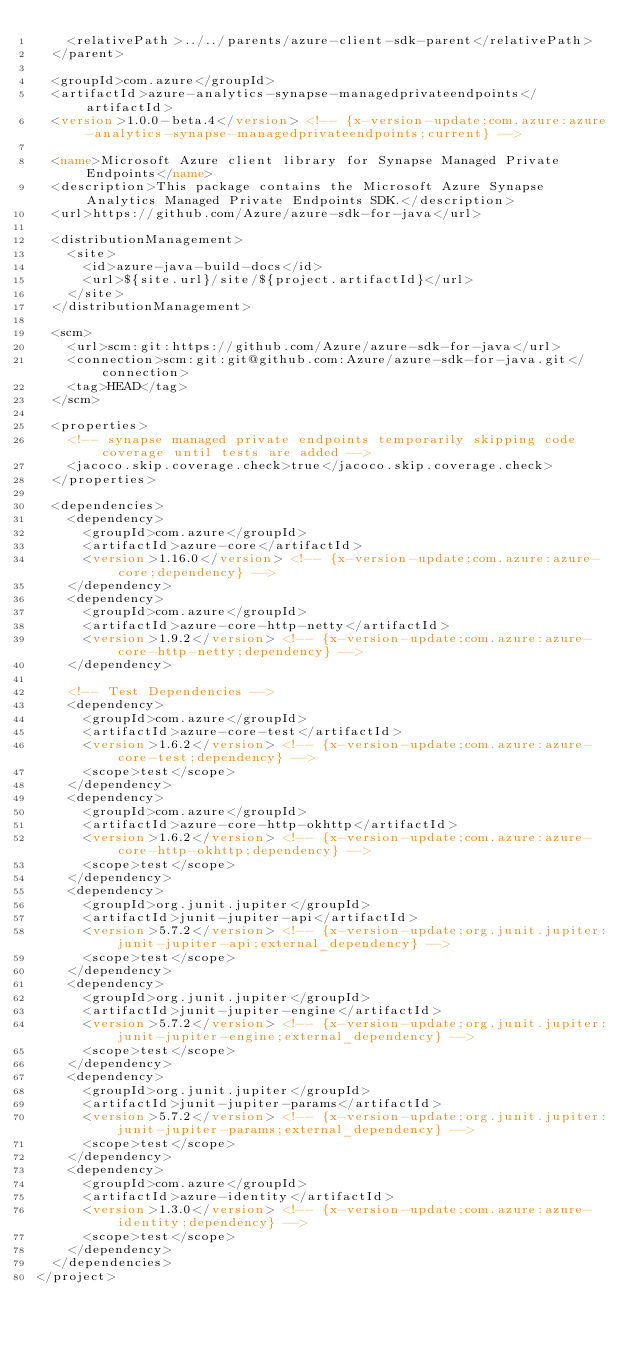Convert code to text. <code><loc_0><loc_0><loc_500><loc_500><_XML_>    <relativePath>../../parents/azure-client-sdk-parent</relativePath>
  </parent>

  <groupId>com.azure</groupId>
  <artifactId>azure-analytics-synapse-managedprivateendpoints</artifactId>
  <version>1.0.0-beta.4</version> <!-- {x-version-update;com.azure:azure-analytics-synapse-managedprivateendpoints;current} -->

  <name>Microsoft Azure client library for Synapse Managed Private Endpoints</name>
  <description>This package contains the Microsoft Azure Synapse Analytics Managed Private Endpoints SDK.</description>
  <url>https://github.com/Azure/azure-sdk-for-java</url>

  <distributionManagement>
    <site>
      <id>azure-java-build-docs</id>
      <url>${site.url}/site/${project.artifactId}</url>
    </site>
  </distributionManagement>

  <scm>
    <url>scm:git:https://github.com/Azure/azure-sdk-for-java</url>
    <connection>scm:git:git@github.com:Azure/azure-sdk-for-java.git</connection>
    <tag>HEAD</tag>
  </scm>

  <properties>
    <!-- synapse managed private endpoints temporarily skipping code coverage until tests are added -->
    <jacoco.skip.coverage.check>true</jacoco.skip.coverage.check>
  </properties>

  <dependencies>
    <dependency>
      <groupId>com.azure</groupId>
      <artifactId>azure-core</artifactId>
      <version>1.16.0</version> <!-- {x-version-update;com.azure:azure-core;dependency} -->
    </dependency>
    <dependency>
      <groupId>com.azure</groupId>
      <artifactId>azure-core-http-netty</artifactId>
      <version>1.9.2</version> <!-- {x-version-update;com.azure:azure-core-http-netty;dependency} -->
    </dependency>

    <!-- Test Dependencies -->
    <dependency>
      <groupId>com.azure</groupId>
      <artifactId>azure-core-test</artifactId>
      <version>1.6.2</version> <!-- {x-version-update;com.azure:azure-core-test;dependency} -->
      <scope>test</scope>
    </dependency>
    <dependency>
      <groupId>com.azure</groupId>
      <artifactId>azure-core-http-okhttp</artifactId>
      <version>1.6.2</version> <!-- {x-version-update;com.azure:azure-core-http-okhttp;dependency} -->
      <scope>test</scope>
    </dependency>
    <dependency>
      <groupId>org.junit.jupiter</groupId>
      <artifactId>junit-jupiter-api</artifactId>
      <version>5.7.2</version> <!-- {x-version-update;org.junit.jupiter:junit-jupiter-api;external_dependency} -->
      <scope>test</scope>
    </dependency>
    <dependency>
      <groupId>org.junit.jupiter</groupId>
      <artifactId>junit-jupiter-engine</artifactId>
      <version>5.7.2</version> <!-- {x-version-update;org.junit.jupiter:junit-jupiter-engine;external_dependency} -->
      <scope>test</scope>
    </dependency>
    <dependency>
      <groupId>org.junit.jupiter</groupId>
      <artifactId>junit-jupiter-params</artifactId>
      <version>5.7.2</version> <!-- {x-version-update;org.junit.jupiter:junit-jupiter-params;external_dependency} -->
      <scope>test</scope>
    </dependency>
    <dependency>
      <groupId>com.azure</groupId>
      <artifactId>azure-identity</artifactId>
      <version>1.3.0</version> <!-- {x-version-update;com.azure:azure-identity;dependency} -->
      <scope>test</scope>
    </dependency>
  </dependencies>
</project>
</code> 